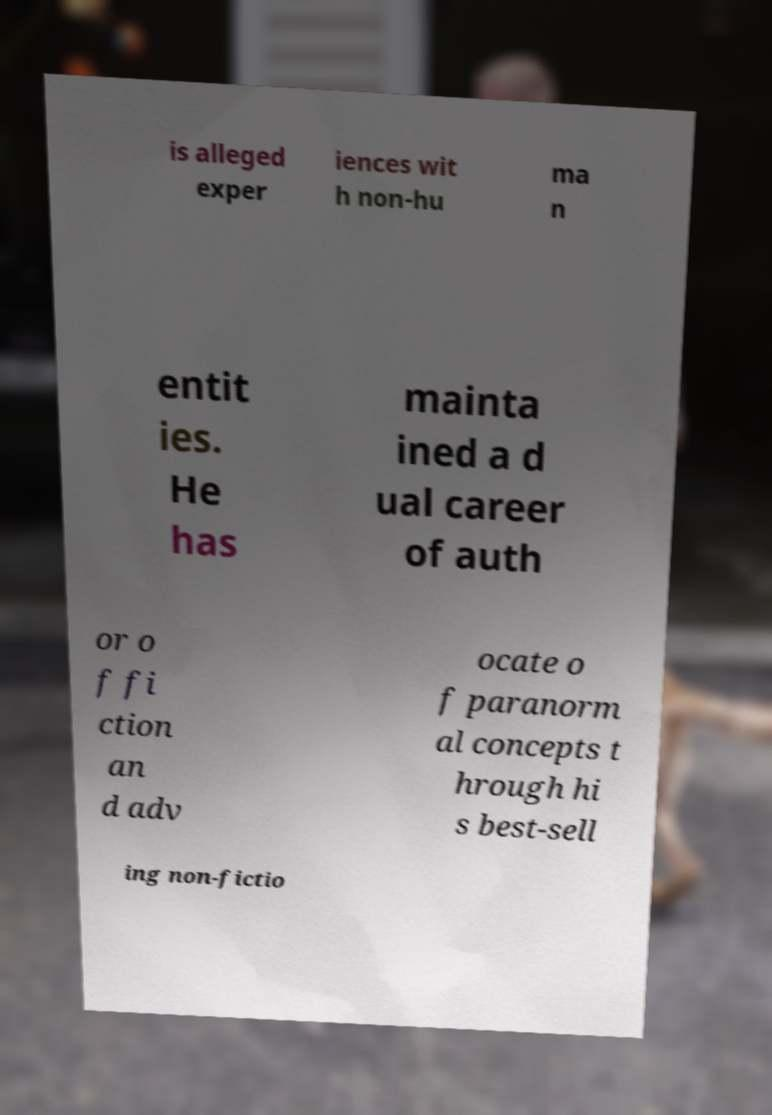There's text embedded in this image that I need extracted. Can you transcribe it verbatim? is alleged exper iences wit h non-hu ma n entit ies. He has mainta ined a d ual career of auth or o f fi ction an d adv ocate o f paranorm al concepts t hrough hi s best-sell ing non-fictio 